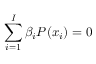Convert formula to latex. <formula><loc_0><loc_0><loc_500><loc_500>\sum _ { i = 1 } ^ { I } \beta _ { i } P ( x _ { i } ) = 0</formula> 